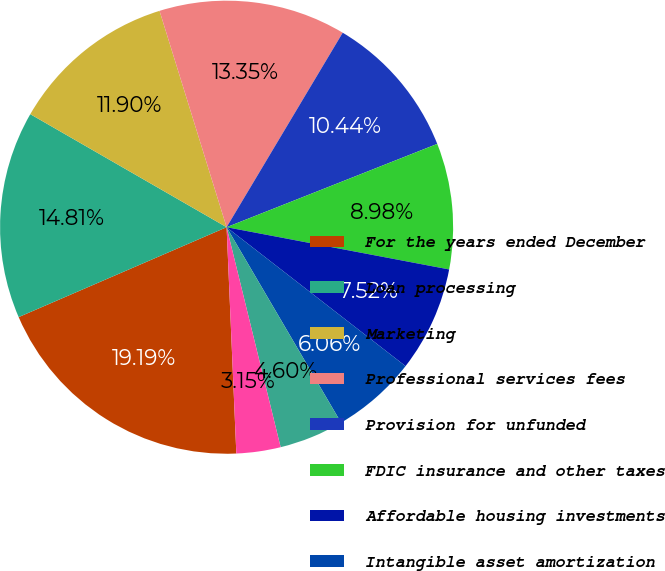Convert chart. <chart><loc_0><loc_0><loc_500><loc_500><pie_chart><fcel>For the years ended December<fcel>Loan processing<fcel>Marketing<fcel>Professional services fees<fcel>Provision for unfunded<fcel>FDIC insurance and other taxes<fcel>Affordable housing investments<fcel>Intangible asset amortization<fcel>Travel<fcel>Recruitment and education<nl><fcel>19.19%<fcel>14.81%<fcel>11.9%<fcel>13.35%<fcel>10.44%<fcel>8.98%<fcel>7.52%<fcel>6.06%<fcel>4.6%<fcel>3.15%<nl></chart> 